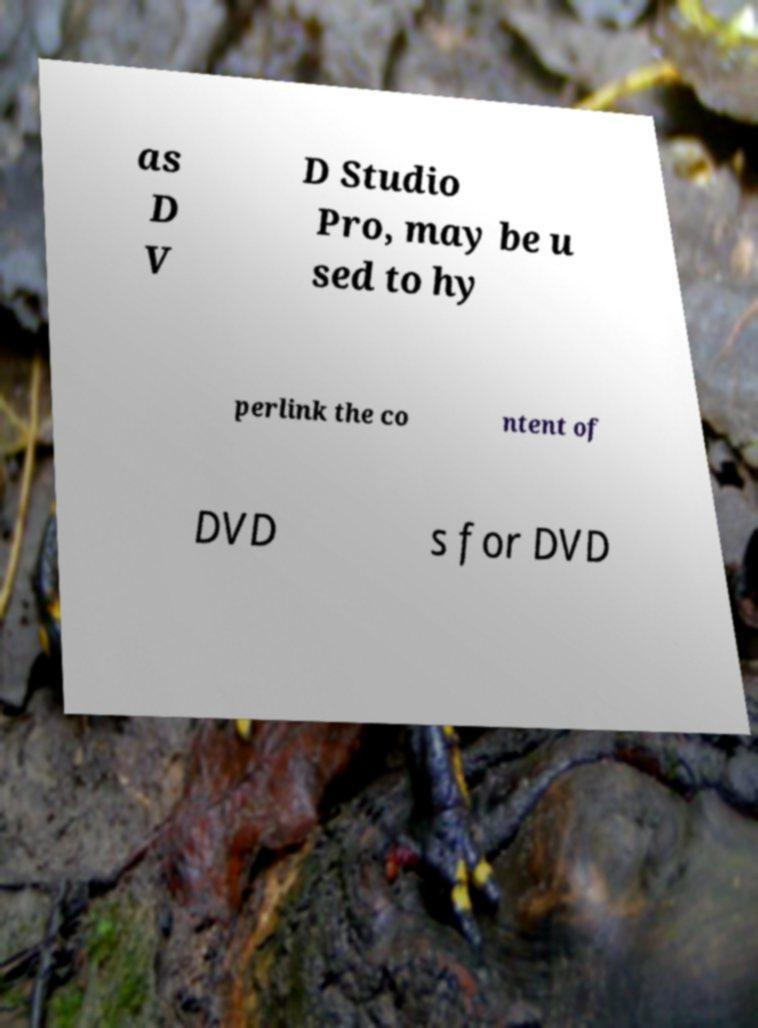Could you extract and type out the text from this image? as D V D Studio Pro, may be u sed to hy perlink the co ntent of DVD s for DVD 